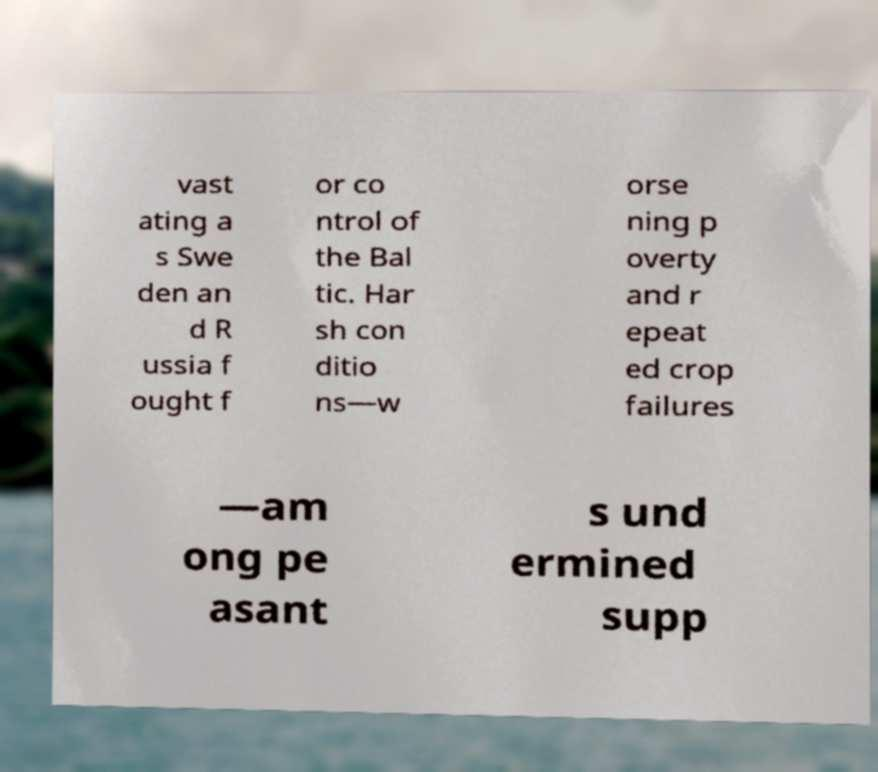Please read and relay the text visible in this image. What does it say? vast ating a s Swe den an d R ussia f ought f or co ntrol of the Bal tic. Har sh con ditio ns—w orse ning p overty and r epeat ed crop failures —am ong pe asant s und ermined supp 